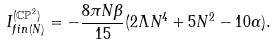Convert formula to latex. <formula><loc_0><loc_0><loc_500><loc_500>I _ { f i n ( N ) } ^ { ( \mathbb { C P } ^ { 2 } ) } = - \frac { 8 \pi N \beta } { 1 5 } ( 2 \Lambda N ^ { 4 } + 5 N ^ { 2 } - 1 0 \alpha ) .</formula> 